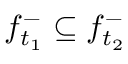Convert formula to latex. <formula><loc_0><loc_0><loc_500><loc_500>f _ { t _ { 1 } } ^ { - } \subseteq f _ { t _ { 2 } } ^ { - }</formula> 